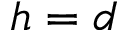<formula> <loc_0><loc_0><loc_500><loc_500>h = d</formula> 